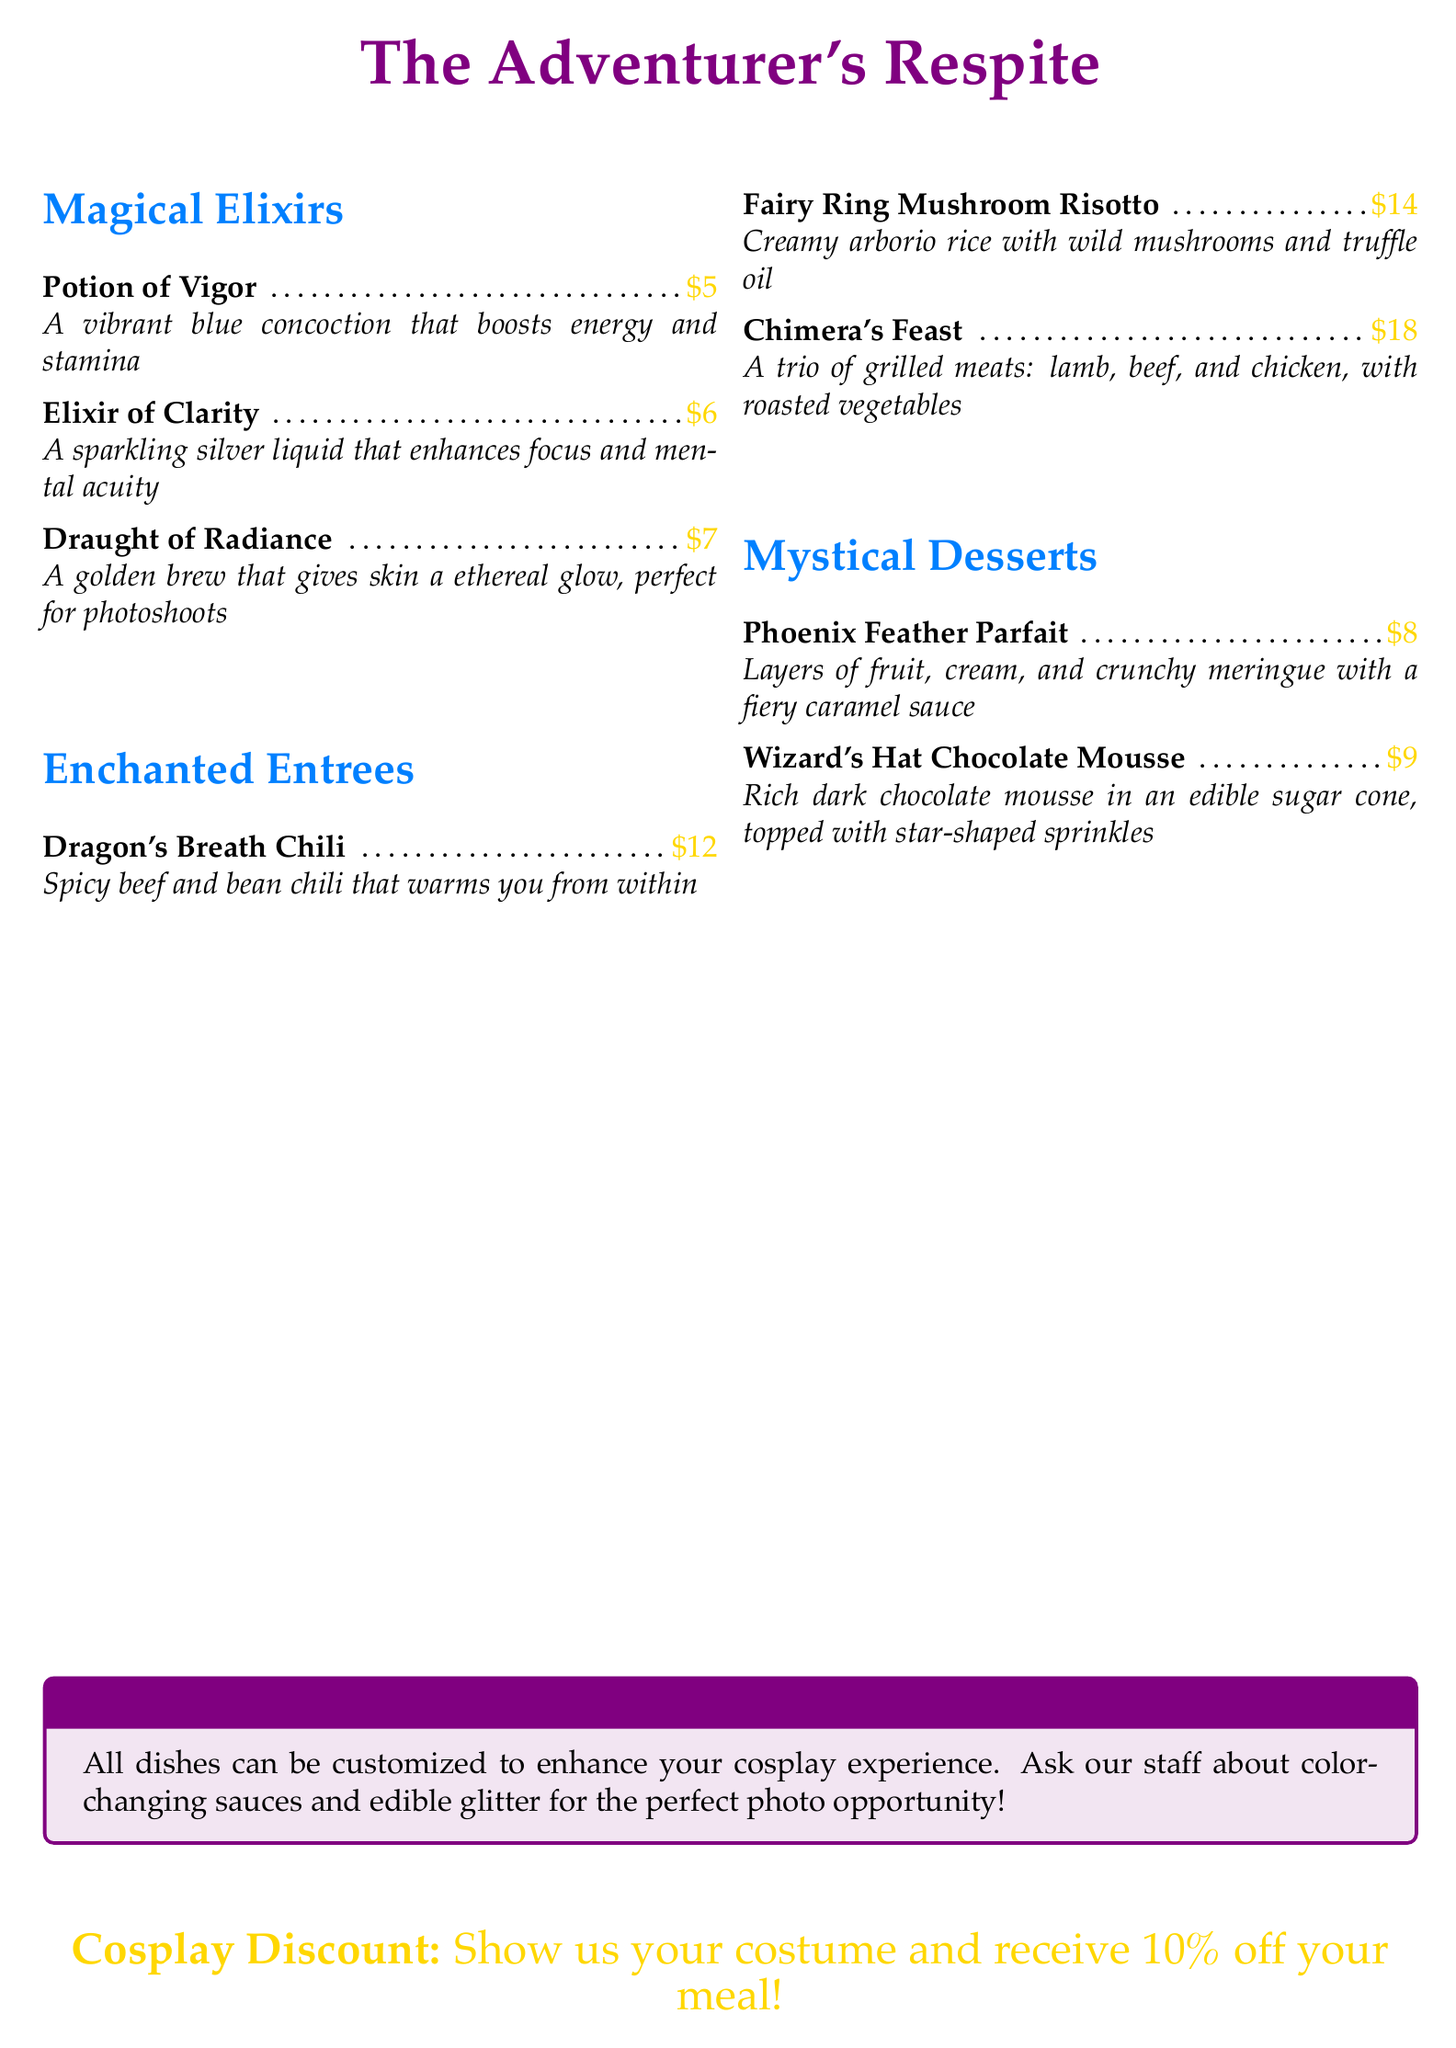What is the name of the restaurant? The restaurant name is prominently displayed at the top of the menu.
Answer: The Adventurer's Respite How much does the Potion of Vigor cost? The price is listed next to the Potion of Vigor in the Magical Elixirs section.
Answer: $5 What is the main ingredient in the Dragon's Breath Chili? The menu description indicates that it is made with spicy beef and beans.
Answer: Beef What type of meal is the Fairy Ring Mushroom Risotto? The menu categorizes it under Enchanted Entrees, indicating it is a main dish.
Answer: Entree How many Mystical Desserts are listed on the menu? The menu lists two distinct desserts under the Mystical Desserts section.
Answer: 2 What is the special note about customizing dishes? The note informs customers they can enhance their cosplay experience with certain features.
Answer: Color-changing sauces and edible glitter What discount do cosplayers receive? The menu offers a specific discount for patrons in costume.
Answer: 10% off Which Elixir is designed to enhance focus? The menu explicitly states that the Elixir of Clarity enhances focus.
Answer: Elixir of Clarity What is unique about the Draught of Radiance? The menu mentions that it gives the skin an ethereal glow, especially suitable for photoshoots.
Answer: Ethereal glow 